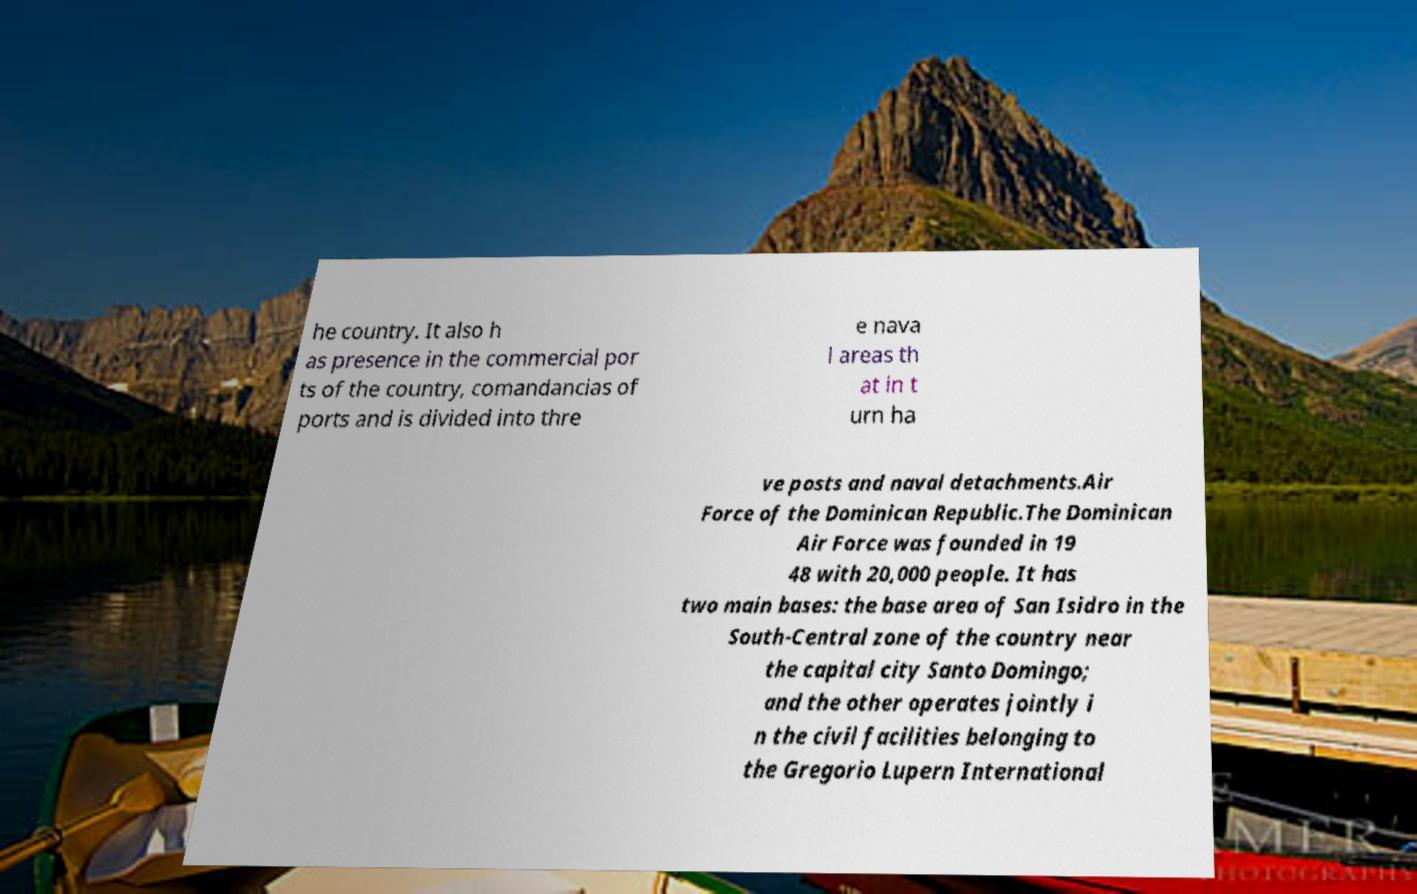What messages or text are displayed in this image? I need them in a readable, typed format. he country. It also h as presence in the commercial por ts of the country, comandancias of ports and is divided into thre e nava l areas th at in t urn ha ve posts and naval detachments.Air Force of the Dominican Republic.The Dominican Air Force was founded in 19 48 with 20,000 people. It has two main bases: the base area of San Isidro in the South-Central zone of the country near the capital city Santo Domingo; and the other operates jointly i n the civil facilities belonging to the Gregorio Lupern International 